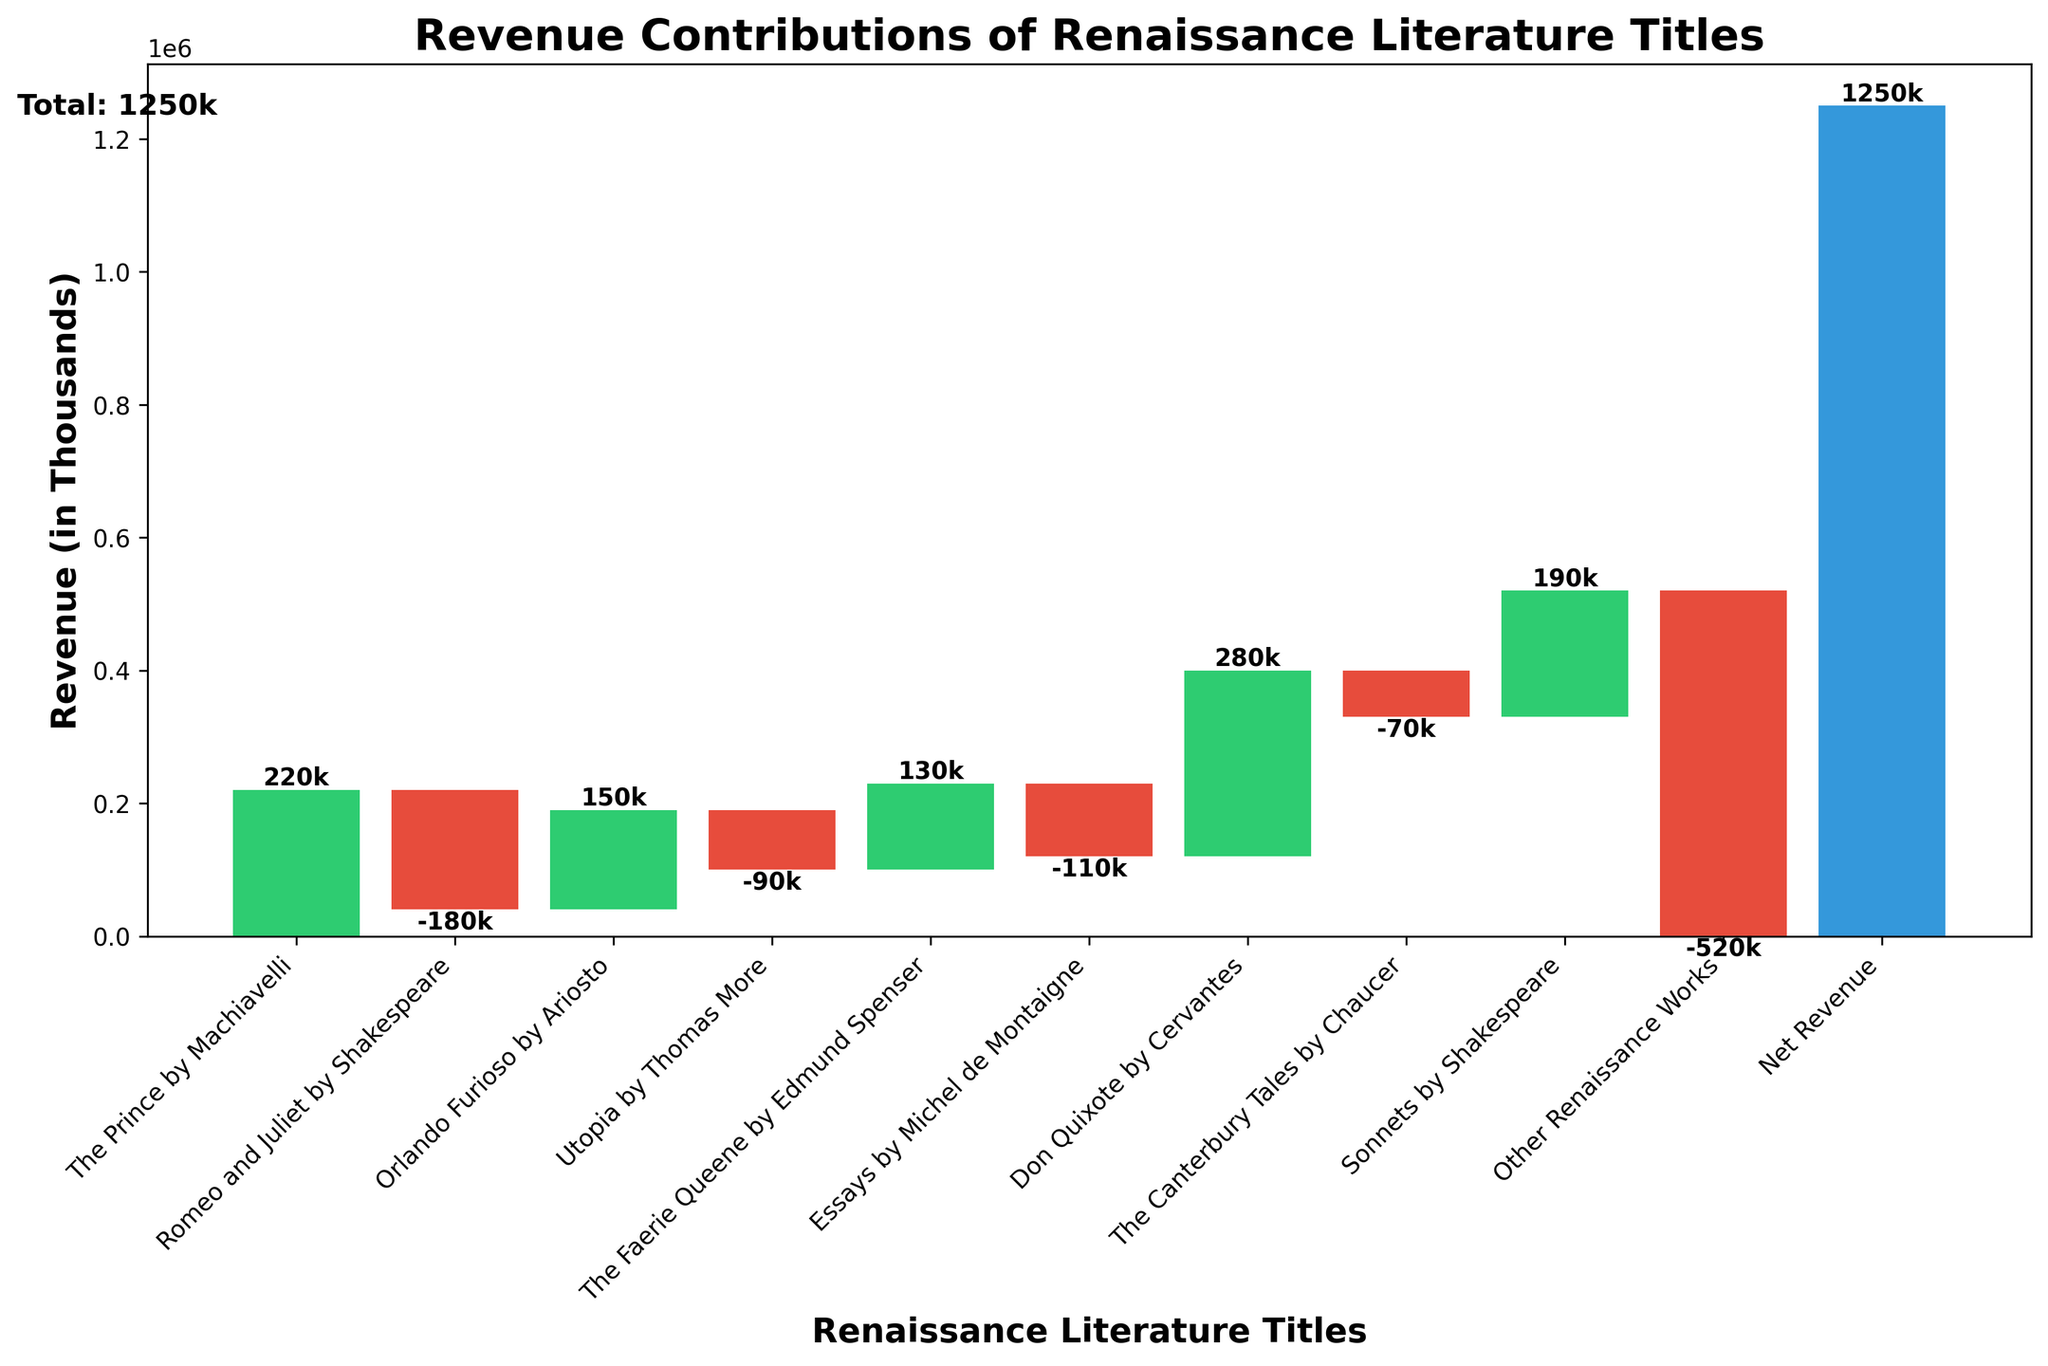What is the total revenue for Renaissance literature sales? The total revenue for Renaissance literature sales is marked at the left side of the figure.
Answer: 1250000 Which title has the highest positive revenue contribution? By looking at the heights of the green bars, "Don Quixote by Cervantes" is the highest among them, indicating it has the highest positive revenue contribution.
Answer: Don Quixote by Cervantes How much net revenue is shown in the chart? The net revenue is displayed as a distinct bar and is labeled with its value.
Answer: 1250000 Which title has the lowest revenue contribution? By observing the smallest red bar, "Other Renaissance Works" has the lowest revenue contribution.
Answer: Other Renaissance Works What is the cumulative revenue change contributed by "Romeo and Juliet by Shakespeare" and "Utopia by Thomas More"? Find the red bars for both titles and sum their revenue contributions (-180000) + (-90000).
Answer: -270000 What is the revenue difference between "The Prince by Machiavelli" and "Essays by Michel de Montaigne"? Subtract the revenue contribution of "Essays by Michel de Montaigne" from "The Prince by Machiavelli" (220000) - (-110000).
Answer: 330000 How many titles contributed positively to the revenue? Count the number of green bars in the figure. There are four: "The Prince by Machiavelli," "Orlando Furioso by Ariosto," "The Faerie Queene by Edmund Spenser," and "Don Quixote by Cervantes".
Answer: 4 Which title has a higher revenue contribution: "The Faerie Queene by Edmund Spenser" or "Sonnets by Shakespeare"? Compare the heights of the green bars for both titles. "Sonnets by Shakespeare" has a higher value than "The Faerie Queene by Edmund Spenser".
Answer: Sonnets by Shakespeare What is the combined revenue contribution of all titles that have negative revenues? Sum the contributions of all red bars: (-180000) + (-90000) + (-110000) + (-70000) + (-520000).
Answer: -970000 What does the blue bar at the end represent? The blue bar is labeled as "Net Revenue," representing the cumulative revenue after summing all individual contributions.
Answer: Net Revenue 